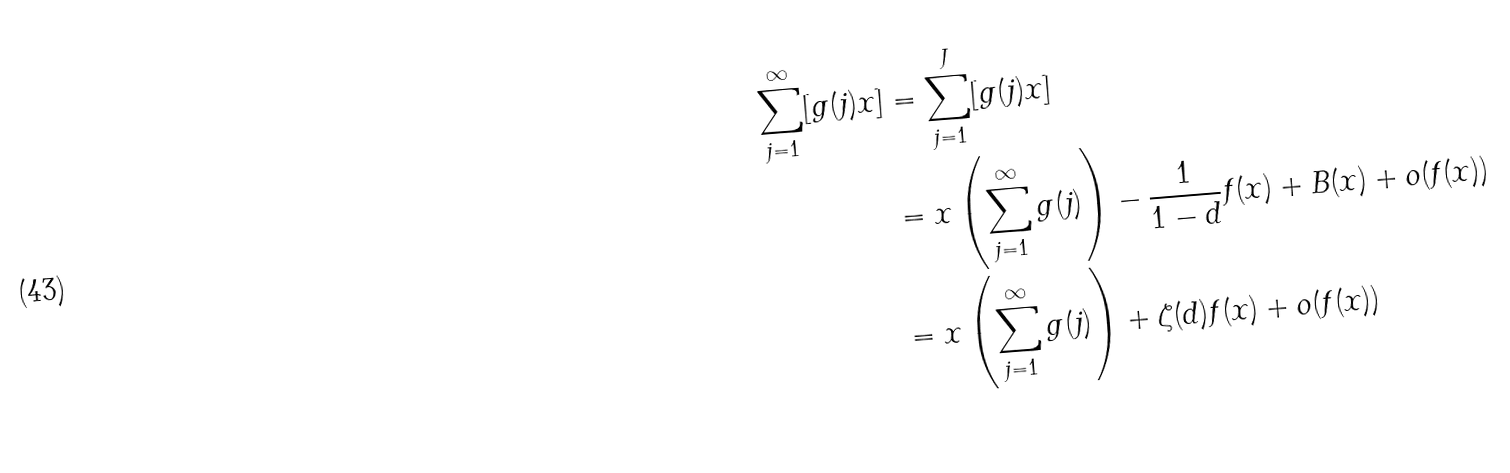<formula> <loc_0><loc_0><loc_500><loc_500>\sum _ { j = 1 } ^ { \infty } [ g ( j ) x ] & = \sum _ { j = 1 } ^ { J } [ g ( j ) x ] \\ & = x \left ( \sum _ { j = 1 } ^ { \infty } g ( j ) \right ) - \frac { 1 } { 1 - d } f ( x ) + B ( x ) + o ( f ( x ) ) \\ & = x \left ( \sum _ { j = 1 } ^ { \infty } g ( j ) \right ) + \zeta ( d ) f ( x ) + o ( f ( x ) )</formula> 